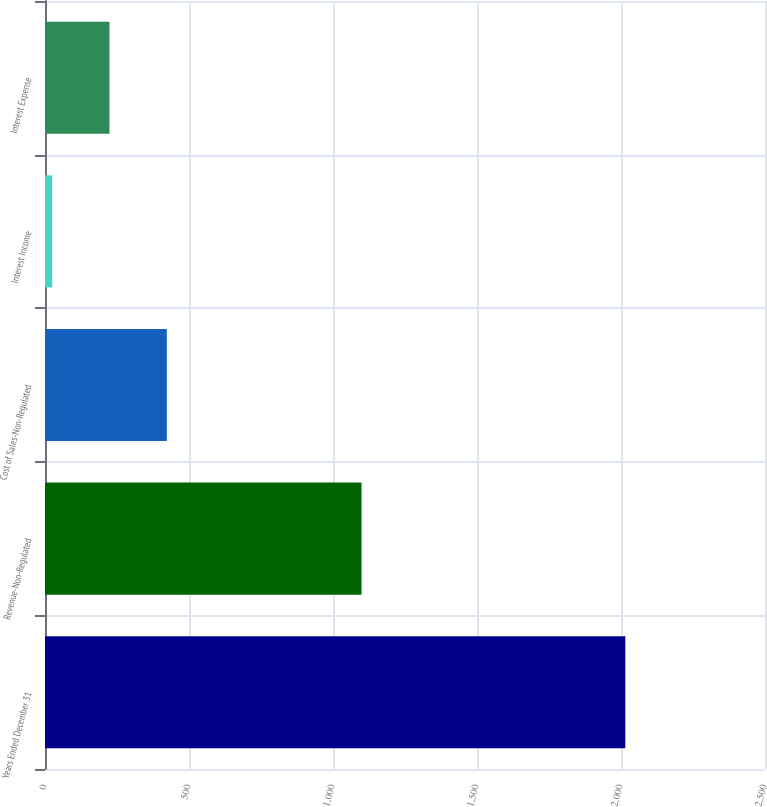Convert chart to OTSL. <chart><loc_0><loc_0><loc_500><loc_500><bar_chart><fcel>Years Ended December 31<fcel>Revenue-Non-Regulated<fcel>Cost of Sales-Non-Regulated<fcel>Interest Income<fcel>Interest Expense<nl><fcel>2015<fcel>1099<fcel>423<fcel>25<fcel>224<nl></chart> 